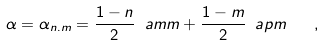<formula> <loc_0><loc_0><loc_500><loc_500>\alpha = \alpha _ { n . m } = \frac { 1 - n } { 2 } \ a m m + \frac { 1 - m } { 2 } \ a p m \quad ,</formula> 